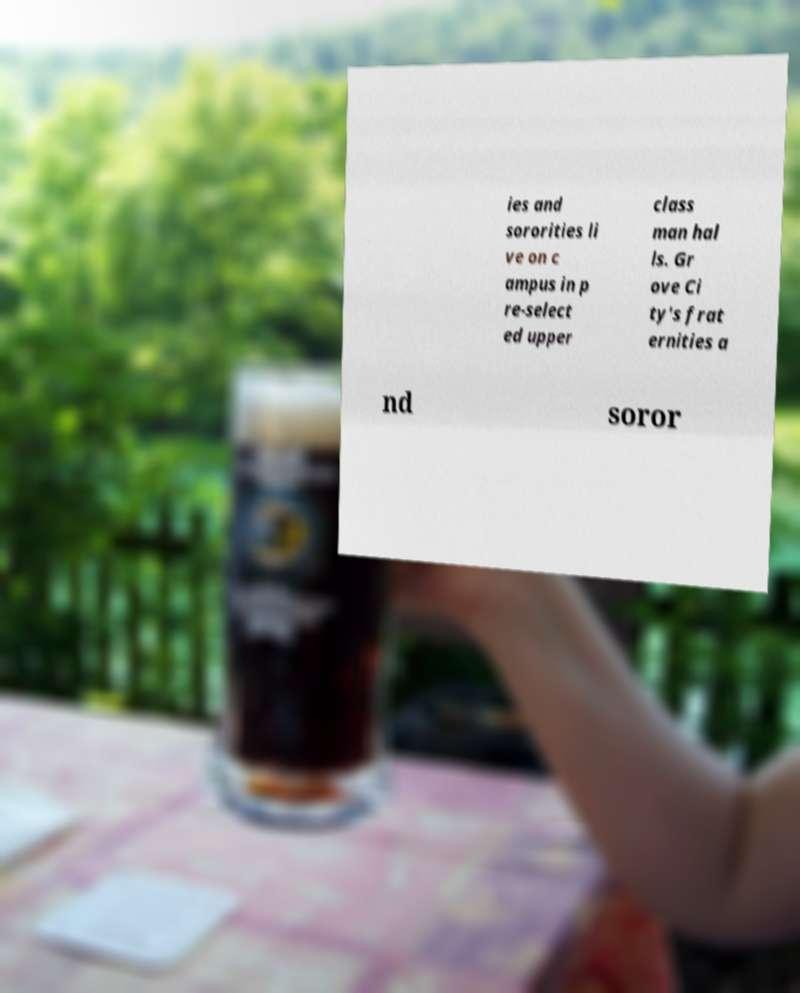Please identify and transcribe the text found in this image. ies and sororities li ve on c ampus in p re-select ed upper class man hal ls. Gr ove Ci ty's frat ernities a nd soror 